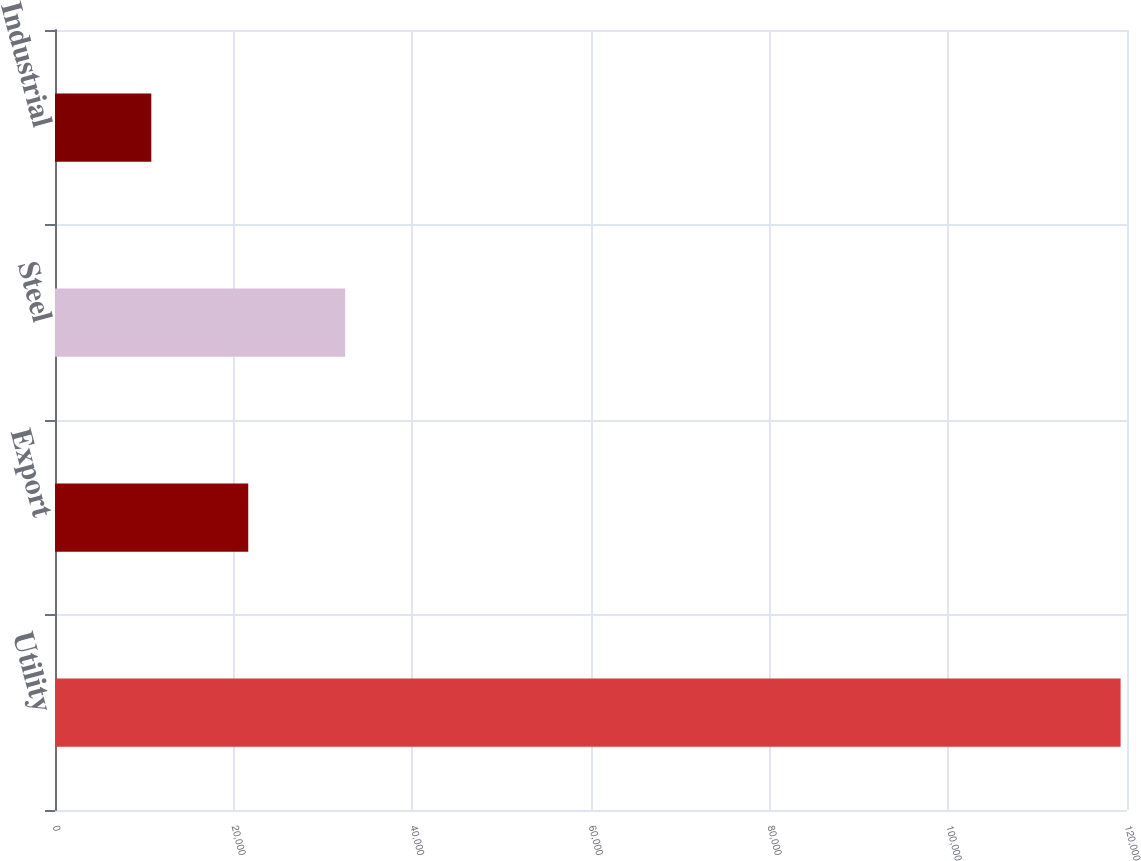Convert chart. <chart><loc_0><loc_0><loc_500><loc_500><bar_chart><fcel>Utility<fcel>Export<fcel>Steel<fcel>Industrial<nl><fcel>119284<fcel>21631.3<fcel>32481.6<fcel>10781<nl></chart> 